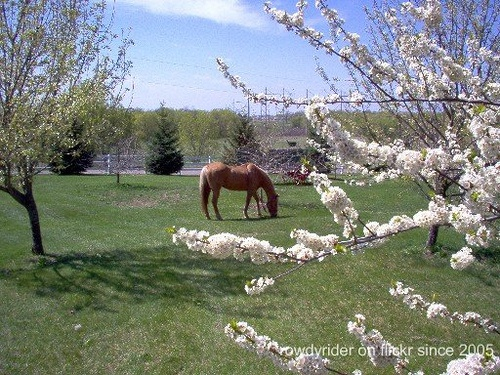Describe the objects in this image and their specific colors. I can see a horse in gray, black, and maroon tones in this image. 